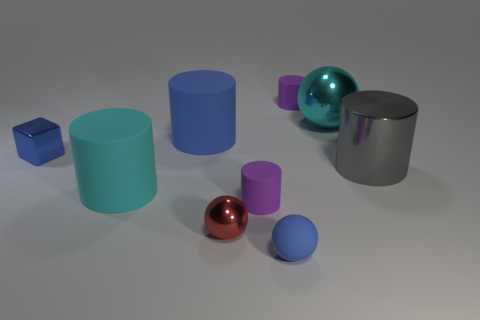What is the cyan object behind the big gray metal thing made of?
Your answer should be compact. Metal. What number of other cyan objects are the same shape as the cyan rubber object?
Give a very brief answer. 0. Is the block the same color as the small matte sphere?
Ensure brevity in your answer.  Yes. What material is the small blue object that is right of the metallic ball on the left side of the small purple object that is behind the tiny blue metallic block?
Your answer should be compact. Rubber. Are there any small matte objects on the right side of the big cyan metal object?
Your response must be concise. No. There is a red metallic object that is the same size as the blue shiny object; what is its shape?
Provide a short and direct response. Sphere. Is the material of the big sphere the same as the big blue cylinder?
Give a very brief answer. No. What number of rubber things are purple things or blue objects?
Offer a very short reply. 4. The large object that is the same color as the cube is what shape?
Ensure brevity in your answer.  Cylinder. There is a large cylinder that is behind the small blue cube; does it have the same color as the matte ball?
Provide a succinct answer. Yes. 